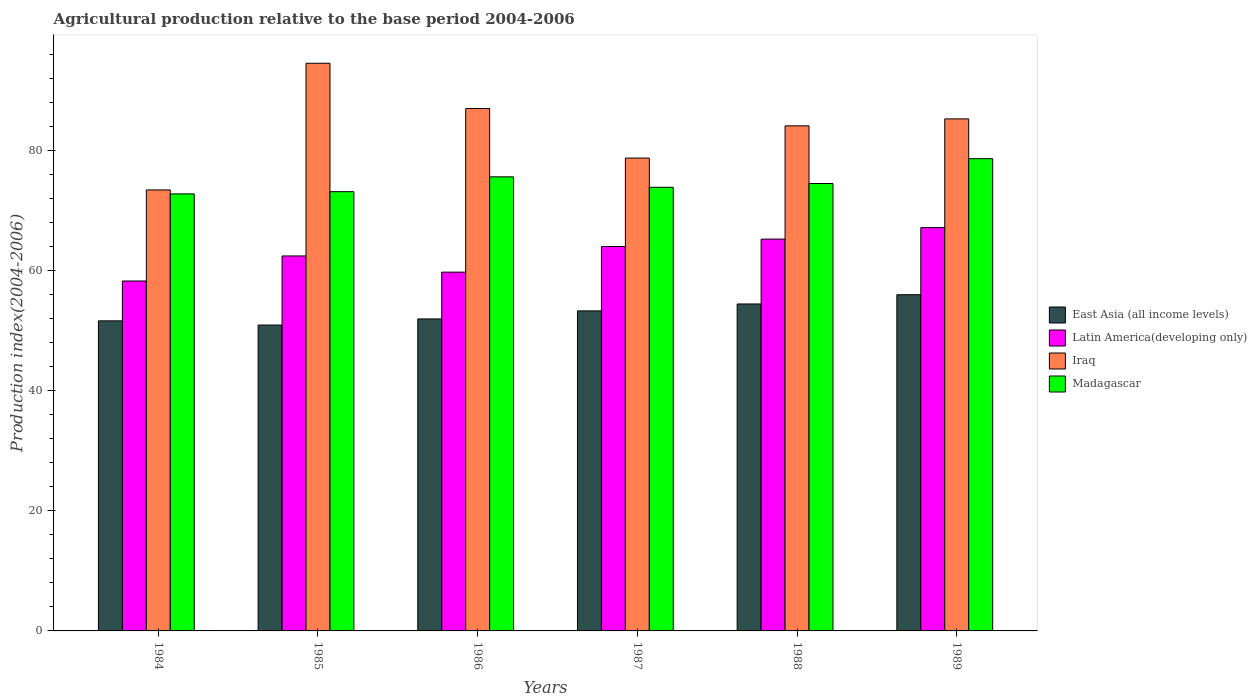How many groups of bars are there?
Keep it short and to the point. 6. How many bars are there on the 6th tick from the left?
Your response must be concise. 4. How many bars are there on the 3rd tick from the right?
Keep it short and to the point. 4. What is the label of the 6th group of bars from the left?
Provide a succinct answer. 1989. What is the agricultural production index in Latin America(developing only) in 1984?
Give a very brief answer. 58.31. Across all years, what is the maximum agricultural production index in Latin America(developing only)?
Your answer should be compact. 67.21. Across all years, what is the minimum agricultural production index in Latin America(developing only)?
Your answer should be very brief. 58.31. In which year was the agricultural production index in Iraq maximum?
Provide a succinct answer. 1985. What is the total agricultural production index in Latin America(developing only) in the graph?
Your answer should be very brief. 377.16. What is the difference between the agricultural production index in Madagascar in 1986 and that in 1988?
Keep it short and to the point. 1.11. What is the difference between the agricultural production index in East Asia (all income levels) in 1986 and the agricultural production index in Madagascar in 1984?
Offer a terse response. -20.84. What is the average agricultural production index in Madagascar per year?
Your response must be concise. 74.81. In the year 1988, what is the difference between the agricultural production index in Iraq and agricultural production index in Latin America(developing only)?
Your answer should be very brief. 18.87. In how many years, is the agricultural production index in East Asia (all income levels) greater than 28?
Keep it short and to the point. 6. What is the ratio of the agricultural production index in Iraq in 1986 to that in 1989?
Keep it short and to the point. 1.02. Is the difference between the agricultural production index in Iraq in 1988 and 1989 greater than the difference between the agricultural production index in Latin America(developing only) in 1988 and 1989?
Your answer should be very brief. Yes. What is the difference between the highest and the second highest agricultural production index in East Asia (all income levels)?
Ensure brevity in your answer.  1.54. What is the difference between the highest and the lowest agricultural production index in East Asia (all income levels)?
Your answer should be compact. 5.06. Is the sum of the agricultural production index in Latin America(developing only) in 1985 and 1987 greater than the maximum agricultural production index in Madagascar across all years?
Provide a short and direct response. Yes. What does the 1st bar from the left in 1988 represents?
Your response must be concise. East Asia (all income levels). What does the 4th bar from the right in 1989 represents?
Your response must be concise. East Asia (all income levels). How many bars are there?
Ensure brevity in your answer.  24. Are all the bars in the graph horizontal?
Offer a very short reply. No. How many years are there in the graph?
Offer a terse response. 6. Does the graph contain any zero values?
Provide a succinct answer. No. Does the graph contain grids?
Make the answer very short. No. What is the title of the graph?
Your response must be concise. Agricultural production relative to the base period 2004-2006. Does "Papua New Guinea" appear as one of the legend labels in the graph?
Your response must be concise. No. What is the label or title of the Y-axis?
Offer a terse response. Production index(2004-2006). What is the Production index(2004-2006) of East Asia (all income levels) in 1984?
Your response must be concise. 51.67. What is the Production index(2004-2006) of Latin America(developing only) in 1984?
Make the answer very short. 58.31. What is the Production index(2004-2006) of Iraq in 1984?
Make the answer very short. 73.49. What is the Production index(2004-2006) of Madagascar in 1984?
Keep it short and to the point. 72.83. What is the Production index(2004-2006) in East Asia (all income levels) in 1985?
Make the answer very short. 50.97. What is the Production index(2004-2006) of Latin America(developing only) in 1985?
Offer a terse response. 62.49. What is the Production index(2004-2006) of Iraq in 1985?
Your answer should be compact. 94.6. What is the Production index(2004-2006) of Madagascar in 1985?
Your answer should be very brief. 73.2. What is the Production index(2004-2006) of East Asia (all income levels) in 1986?
Keep it short and to the point. 51.99. What is the Production index(2004-2006) of Latin America(developing only) in 1986?
Ensure brevity in your answer.  59.79. What is the Production index(2004-2006) in Iraq in 1986?
Offer a very short reply. 87.06. What is the Production index(2004-2006) of Madagascar in 1986?
Provide a short and direct response. 75.67. What is the Production index(2004-2006) in East Asia (all income levels) in 1987?
Offer a terse response. 53.33. What is the Production index(2004-2006) in Latin America(developing only) in 1987?
Give a very brief answer. 64.06. What is the Production index(2004-2006) in Iraq in 1987?
Offer a very short reply. 78.8. What is the Production index(2004-2006) in Madagascar in 1987?
Provide a succinct answer. 73.93. What is the Production index(2004-2006) of East Asia (all income levels) in 1988?
Provide a short and direct response. 54.48. What is the Production index(2004-2006) in Latin America(developing only) in 1988?
Your answer should be very brief. 65.3. What is the Production index(2004-2006) in Iraq in 1988?
Offer a very short reply. 84.17. What is the Production index(2004-2006) of Madagascar in 1988?
Keep it short and to the point. 74.56. What is the Production index(2004-2006) in East Asia (all income levels) in 1989?
Provide a succinct answer. 56.03. What is the Production index(2004-2006) of Latin America(developing only) in 1989?
Give a very brief answer. 67.21. What is the Production index(2004-2006) in Iraq in 1989?
Provide a short and direct response. 85.33. What is the Production index(2004-2006) of Madagascar in 1989?
Offer a terse response. 78.7. Across all years, what is the maximum Production index(2004-2006) in East Asia (all income levels)?
Provide a succinct answer. 56.03. Across all years, what is the maximum Production index(2004-2006) of Latin America(developing only)?
Keep it short and to the point. 67.21. Across all years, what is the maximum Production index(2004-2006) of Iraq?
Provide a short and direct response. 94.6. Across all years, what is the maximum Production index(2004-2006) of Madagascar?
Offer a very short reply. 78.7. Across all years, what is the minimum Production index(2004-2006) of East Asia (all income levels)?
Ensure brevity in your answer.  50.97. Across all years, what is the minimum Production index(2004-2006) of Latin America(developing only)?
Your answer should be very brief. 58.31. Across all years, what is the minimum Production index(2004-2006) in Iraq?
Give a very brief answer. 73.49. Across all years, what is the minimum Production index(2004-2006) in Madagascar?
Provide a succinct answer. 72.83. What is the total Production index(2004-2006) in East Asia (all income levels) in the graph?
Give a very brief answer. 318.48. What is the total Production index(2004-2006) in Latin America(developing only) in the graph?
Provide a succinct answer. 377.16. What is the total Production index(2004-2006) in Iraq in the graph?
Offer a terse response. 503.45. What is the total Production index(2004-2006) in Madagascar in the graph?
Offer a very short reply. 448.89. What is the difference between the Production index(2004-2006) in East Asia (all income levels) in 1984 and that in 1985?
Offer a terse response. 0.7. What is the difference between the Production index(2004-2006) in Latin America(developing only) in 1984 and that in 1985?
Make the answer very short. -4.17. What is the difference between the Production index(2004-2006) of Iraq in 1984 and that in 1985?
Provide a short and direct response. -21.11. What is the difference between the Production index(2004-2006) in Madagascar in 1984 and that in 1985?
Offer a terse response. -0.37. What is the difference between the Production index(2004-2006) in East Asia (all income levels) in 1984 and that in 1986?
Make the answer very short. -0.32. What is the difference between the Production index(2004-2006) in Latin America(developing only) in 1984 and that in 1986?
Offer a terse response. -1.48. What is the difference between the Production index(2004-2006) in Iraq in 1984 and that in 1986?
Give a very brief answer. -13.57. What is the difference between the Production index(2004-2006) of Madagascar in 1984 and that in 1986?
Your response must be concise. -2.84. What is the difference between the Production index(2004-2006) in East Asia (all income levels) in 1984 and that in 1987?
Keep it short and to the point. -1.66. What is the difference between the Production index(2004-2006) in Latin America(developing only) in 1984 and that in 1987?
Your answer should be very brief. -5.75. What is the difference between the Production index(2004-2006) in Iraq in 1984 and that in 1987?
Ensure brevity in your answer.  -5.31. What is the difference between the Production index(2004-2006) in East Asia (all income levels) in 1984 and that in 1988?
Make the answer very short. -2.81. What is the difference between the Production index(2004-2006) in Latin America(developing only) in 1984 and that in 1988?
Keep it short and to the point. -6.98. What is the difference between the Production index(2004-2006) in Iraq in 1984 and that in 1988?
Your response must be concise. -10.68. What is the difference between the Production index(2004-2006) in Madagascar in 1984 and that in 1988?
Provide a short and direct response. -1.73. What is the difference between the Production index(2004-2006) in East Asia (all income levels) in 1984 and that in 1989?
Give a very brief answer. -4.36. What is the difference between the Production index(2004-2006) in Latin America(developing only) in 1984 and that in 1989?
Offer a terse response. -8.9. What is the difference between the Production index(2004-2006) of Iraq in 1984 and that in 1989?
Offer a very short reply. -11.84. What is the difference between the Production index(2004-2006) of Madagascar in 1984 and that in 1989?
Offer a very short reply. -5.87. What is the difference between the Production index(2004-2006) of East Asia (all income levels) in 1985 and that in 1986?
Your answer should be compact. -1.02. What is the difference between the Production index(2004-2006) of Latin America(developing only) in 1985 and that in 1986?
Your response must be concise. 2.7. What is the difference between the Production index(2004-2006) in Iraq in 1985 and that in 1986?
Offer a very short reply. 7.54. What is the difference between the Production index(2004-2006) of Madagascar in 1985 and that in 1986?
Your answer should be compact. -2.47. What is the difference between the Production index(2004-2006) of East Asia (all income levels) in 1985 and that in 1987?
Give a very brief answer. -2.36. What is the difference between the Production index(2004-2006) in Latin America(developing only) in 1985 and that in 1987?
Make the answer very short. -1.57. What is the difference between the Production index(2004-2006) of Iraq in 1985 and that in 1987?
Your answer should be very brief. 15.8. What is the difference between the Production index(2004-2006) of Madagascar in 1985 and that in 1987?
Provide a short and direct response. -0.73. What is the difference between the Production index(2004-2006) in East Asia (all income levels) in 1985 and that in 1988?
Offer a very short reply. -3.51. What is the difference between the Production index(2004-2006) of Latin America(developing only) in 1985 and that in 1988?
Your answer should be very brief. -2.81. What is the difference between the Production index(2004-2006) of Iraq in 1985 and that in 1988?
Provide a short and direct response. 10.43. What is the difference between the Production index(2004-2006) of Madagascar in 1985 and that in 1988?
Ensure brevity in your answer.  -1.36. What is the difference between the Production index(2004-2006) in East Asia (all income levels) in 1985 and that in 1989?
Provide a succinct answer. -5.06. What is the difference between the Production index(2004-2006) of Latin America(developing only) in 1985 and that in 1989?
Ensure brevity in your answer.  -4.72. What is the difference between the Production index(2004-2006) in Iraq in 1985 and that in 1989?
Your answer should be compact. 9.27. What is the difference between the Production index(2004-2006) in East Asia (all income levels) in 1986 and that in 1987?
Your answer should be compact. -1.34. What is the difference between the Production index(2004-2006) of Latin America(developing only) in 1986 and that in 1987?
Your answer should be compact. -4.27. What is the difference between the Production index(2004-2006) in Iraq in 1986 and that in 1987?
Offer a very short reply. 8.26. What is the difference between the Production index(2004-2006) in Madagascar in 1986 and that in 1987?
Give a very brief answer. 1.74. What is the difference between the Production index(2004-2006) in East Asia (all income levels) in 1986 and that in 1988?
Provide a short and direct response. -2.49. What is the difference between the Production index(2004-2006) of Latin America(developing only) in 1986 and that in 1988?
Your answer should be compact. -5.5. What is the difference between the Production index(2004-2006) in Iraq in 1986 and that in 1988?
Your answer should be very brief. 2.89. What is the difference between the Production index(2004-2006) in Madagascar in 1986 and that in 1988?
Keep it short and to the point. 1.11. What is the difference between the Production index(2004-2006) in East Asia (all income levels) in 1986 and that in 1989?
Your answer should be very brief. -4.04. What is the difference between the Production index(2004-2006) of Latin America(developing only) in 1986 and that in 1989?
Your response must be concise. -7.42. What is the difference between the Production index(2004-2006) in Iraq in 1986 and that in 1989?
Offer a terse response. 1.73. What is the difference between the Production index(2004-2006) of Madagascar in 1986 and that in 1989?
Your answer should be very brief. -3.03. What is the difference between the Production index(2004-2006) of East Asia (all income levels) in 1987 and that in 1988?
Make the answer very short. -1.15. What is the difference between the Production index(2004-2006) in Latin America(developing only) in 1987 and that in 1988?
Keep it short and to the point. -1.24. What is the difference between the Production index(2004-2006) of Iraq in 1987 and that in 1988?
Offer a terse response. -5.37. What is the difference between the Production index(2004-2006) in Madagascar in 1987 and that in 1988?
Provide a short and direct response. -0.63. What is the difference between the Production index(2004-2006) of East Asia (all income levels) in 1987 and that in 1989?
Make the answer very short. -2.7. What is the difference between the Production index(2004-2006) of Latin America(developing only) in 1987 and that in 1989?
Give a very brief answer. -3.15. What is the difference between the Production index(2004-2006) in Iraq in 1987 and that in 1989?
Keep it short and to the point. -6.53. What is the difference between the Production index(2004-2006) in Madagascar in 1987 and that in 1989?
Keep it short and to the point. -4.77. What is the difference between the Production index(2004-2006) of East Asia (all income levels) in 1988 and that in 1989?
Your response must be concise. -1.54. What is the difference between the Production index(2004-2006) in Latin America(developing only) in 1988 and that in 1989?
Your answer should be very brief. -1.91. What is the difference between the Production index(2004-2006) in Iraq in 1988 and that in 1989?
Your response must be concise. -1.16. What is the difference between the Production index(2004-2006) of Madagascar in 1988 and that in 1989?
Make the answer very short. -4.14. What is the difference between the Production index(2004-2006) in East Asia (all income levels) in 1984 and the Production index(2004-2006) in Latin America(developing only) in 1985?
Your answer should be compact. -10.82. What is the difference between the Production index(2004-2006) in East Asia (all income levels) in 1984 and the Production index(2004-2006) in Iraq in 1985?
Keep it short and to the point. -42.93. What is the difference between the Production index(2004-2006) in East Asia (all income levels) in 1984 and the Production index(2004-2006) in Madagascar in 1985?
Your answer should be compact. -21.53. What is the difference between the Production index(2004-2006) in Latin America(developing only) in 1984 and the Production index(2004-2006) in Iraq in 1985?
Your answer should be very brief. -36.29. What is the difference between the Production index(2004-2006) of Latin America(developing only) in 1984 and the Production index(2004-2006) of Madagascar in 1985?
Your answer should be very brief. -14.89. What is the difference between the Production index(2004-2006) in Iraq in 1984 and the Production index(2004-2006) in Madagascar in 1985?
Keep it short and to the point. 0.29. What is the difference between the Production index(2004-2006) of East Asia (all income levels) in 1984 and the Production index(2004-2006) of Latin America(developing only) in 1986?
Your answer should be very brief. -8.12. What is the difference between the Production index(2004-2006) of East Asia (all income levels) in 1984 and the Production index(2004-2006) of Iraq in 1986?
Make the answer very short. -35.39. What is the difference between the Production index(2004-2006) of East Asia (all income levels) in 1984 and the Production index(2004-2006) of Madagascar in 1986?
Offer a terse response. -24. What is the difference between the Production index(2004-2006) of Latin America(developing only) in 1984 and the Production index(2004-2006) of Iraq in 1986?
Provide a succinct answer. -28.75. What is the difference between the Production index(2004-2006) in Latin America(developing only) in 1984 and the Production index(2004-2006) in Madagascar in 1986?
Give a very brief answer. -17.36. What is the difference between the Production index(2004-2006) of Iraq in 1984 and the Production index(2004-2006) of Madagascar in 1986?
Keep it short and to the point. -2.18. What is the difference between the Production index(2004-2006) in East Asia (all income levels) in 1984 and the Production index(2004-2006) in Latin America(developing only) in 1987?
Make the answer very short. -12.39. What is the difference between the Production index(2004-2006) of East Asia (all income levels) in 1984 and the Production index(2004-2006) of Iraq in 1987?
Offer a terse response. -27.13. What is the difference between the Production index(2004-2006) in East Asia (all income levels) in 1984 and the Production index(2004-2006) in Madagascar in 1987?
Ensure brevity in your answer.  -22.26. What is the difference between the Production index(2004-2006) in Latin America(developing only) in 1984 and the Production index(2004-2006) in Iraq in 1987?
Your answer should be very brief. -20.49. What is the difference between the Production index(2004-2006) of Latin America(developing only) in 1984 and the Production index(2004-2006) of Madagascar in 1987?
Provide a succinct answer. -15.62. What is the difference between the Production index(2004-2006) in Iraq in 1984 and the Production index(2004-2006) in Madagascar in 1987?
Offer a terse response. -0.44. What is the difference between the Production index(2004-2006) in East Asia (all income levels) in 1984 and the Production index(2004-2006) in Latin America(developing only) in 1988?
Your response must be concise. -13.62. What is the difference between the Production index(2004-2006) in East Asia (all income levels) in 1984 and the Production index(2004-2006) in Iraq in 1988?
Your answer should be compact. -32.5. What is the difference between the Production index(2004-2006) of East Asia (all income levels) in 1984 and the Production index(2004-2006) of Madagascar in 1988?
Keep it short and to the point. -22.89. What is the difference between the Production index(2004-2006) in Latin America(developing only) in 1984 and the Production index(2004-2006) in Iraq in 1988?
Make the answer very short. -25.86. What is the difference between the Production index(2004-2006) of Latin America(developing only) in 1984 and the Production index(2004-2006) of Madagascar in 1988?
Offer a terse response. -16.25. What is the difference between the Production index(2004-2006) in Iraq in 1984 and the Production index(2004-2006) in Madagascar in 1988?
Give a very brief answer. -1.07. What is the difference between the Production index(2004-2006) in East Asia (all income levels) in 1984 and the Production index(2004-2006) in Latin America(developing only) in 1989?
Offer a very short reply. -15.54. What is the difference between the Production index(2004-2006) in East Asia (all income levels) in 1984 and the Production index(2004-2006) in Iraq in 1989?
Your answer should be very brief. -33.66. What is the difference between the Production index(2004-2006) of East Asia (all income levels) in 1984 and the Production index(2004-2006) of Madagascar in 1989?
Your answer should be very brief. -27.03. What is the difference between the Production index(2004-2006) of Latin America(developing only) in 1984 and the Production index(2004-2006) of Iraq in 1989?
Keep it short and to the point. -27.02. What is the difference between the Production index(2004-2006) in Latin America(developing only) in 1984 and the Production index(2004-2006) in Madagascar in 1989?
Offer a terse response. -20.39. What is the difference between the Production index(2004-2006) of Iraq in 1984 and the Production index(2004-2006) of Madagascar in 1989?
Keep it short and to the point. -5.21. What is the difference between the Production index(2004-2006) of East Asia (all income levels) in 1985 and the Production index(2004-2006) of Latin America(developing only) in 1986?
Your response must be concise. -8.82. What is the difference between the Production index(2004-2006) in East Asia (all income levels) in 1985 and the Production index(2004-2006) in Iraq in 1986?
Keep it short and to the point. -36.09. What is the difference between the Production index(2004-2006) in East Asia (all income levels) in 1985 and the Production index(2004-2006) in Madagascar in 1986?
Ensure brevity in your answer.  -24.7. What is the difference between the Production index(2004-2006) of Latin America(developing only) in 1985 and the Production index(2004-2006) of Iraq in 1986?
Give a very brief answer. -24.57. What is the difference between the Production index(2004-2006) in Latin America(developing only) in 1985 and the Production index(2004-2006) in Madagascar in 1986?
Provide a succinct answer. -13.18. What is the difference between the Production index(2004-2006) of Iraq in 1985 and the Production index(2004-2006) of Madagascar in 1986?
Keep it short and to the point. 18.93. What is the difference between the Production index(2004-2006) in East Asia (all income levels) in 1985 and the Production index(2004-2006) in Latin America(developing only) in 1987?
Provide a succinct answer. -13.09. What is the difference between the Production index(2004-2006) of East Asia (all income levels) in 1985 and the Production index(2004-2006) of Iraq in 1987?
Provide a short and direct response. -27.83. What is the difference between the Production index(2004-2006) in East Asia (all income levels) in 1985 and the Production index(2004-2006) in Madagascar in 1987?
Keep it short and to the point. -22.96. What is the difference between the Production index(2004-2006) of Latin America(developing only) in 1985 and the Production index(2004-2006) of Iraq in 1987?
Make the answer very short. -16.31. What is the difference between the Production index(2004-2006) of Latin America(developing only) in 1985 and the Production index(2004-2006) of Madagascar in 1987?
Give a very brief answer. -11.44. What is the difference between the Production index(2004-2006) of Iraq in 1985 and the Production index(2004-2006) of Madagascar in 1987?
Give a very brief answer. 20.67. What is the difference between the Production index(2004-2006) in East Asia (all income levels) in 1985 and the Production index(2004-2006) in Latin America(developing only) in 1988?
Your answer should be very brief. -14.32. What is the difference between the Production index(2004-2006) in East Asia (all income levels) in 1985 and the Production index(2004-2006) in Iraq in 1988?
Make the answer very short. -33.2. What is the difference between the Production index(2004-2006) in East Asia (all income levels) in 1985 and the Production index(2004-2006) in Madagascar in 1988?
Give a very brief answer. -23.59. What is the difference between the Production index(2004-2006) of Latin America(developing only) in 1985 and the Production index(2004-2006) of Iraq in 1988?
Offer a very short reply. -21.68. What is the difference between the Production index(2004-2006) in Latin America(developing only) in 1985 and the Production index(2004-2006) in Madagascar in 1988?
Your answer should be compact. -12.07. What is the difference between the Production index(2004-2006) of Iraq in 1985 and the Production index(2004-2006) of Madagascar in 1988?
Your answer should be very brief. 20.04. What is the difference between the Production index(2004-2006) of East Asia (all income levels) in 1985 and the Production index(2004-2006) of Latin America(developing only) in 1989?
Offer a very short reply. -16.24. What is the difference between the Production index(2004-2006) of East Asia (all income levels) in 1985 and the Production index(2004-2006) of Iraq in 1989?
Keep it short and to the point. -34.36. What is the difference between the Production index(2004-2006) in East Asia (all income levels) in 1985 and the Production index(2004-2006) in Madagascar in 1989?
Give a very brief answer. -27.73. What is the difference between the Production index(2004-2006) in Latin America(developing only) in 1985 and the Production index(2004-2006) in Iraq in 1989?
Your answer should be very brief. -22.84. What is the difference between the Production index(2004-2006) in Latin America(developing only) in 1985 and the Production index(2004-2006) in Madagascar in 1989?
Offer a very short reply. -16.21. What is the difference between the Production index(2004-2006) in East Asia (all income levels) in 1986 and the Production index(2004-2006) in Latin America(developing only) in 1987?
Ensure brevity in your answer.  -12.07. What is the difference between the Production index(2004-2006) in East Asia (all income levels) in 1986 and the Production index(2004-2006) in Iraq in 1987?
Offer a very short reply. -26.81. What is the difference between the Production index(2004-2006) in East Asia (all income levels) in 1986 and the Production index(2004-2006) in Madagascar in 1987?
Your answer should be very brief. -21.94. What is the difference between the Production index(2004-2006) in Latin America(developing only) in 1986 and the Production index(2004-2006) in Iraq in 1987?
Offer a very short reply. -19.01. What is the difference between the Production index(2004-2006) in Latin America(developing only) in 1986 and the Production index(2004-2006) in Madagascar in 1987?
Ensure brevity in your answer.  -14.14. What is the difference between the Production index(2004-2006) of Iraq in 1986 and the Production index(2004-2006) of Madagascar in 1987?
Offer a very short reply. 13.13. What is the difference between the Production index(2004-2006) in East Asia (all income levels) in 1986 and the Production index(2004-2006) in Latin America(developing only) in 1988?
Keep it short and to the point. -13.31. What is the difference between the Production index(2004-2006) of East Asia (all income levels) in 1986 and the Production index(2004-2006) of Iraq in 1988?
Provide a succinct answer. -32.18. What is the difference between the Production index(2004-2006) of East Asia (all income levels) in 1986 and the Production index(2004-2006) of Madagascar in 1988?
Your answer should be compact. -22.57. What is the difference between the Production index(2004-2006) in Latin America(developing only) in 1986 and the Production index(2004-2006) in Iraq in 1988?
Make the answer very short. -24.38. What is the difference between the Production index(2004-2006) in Latin America(developing only) in 1986 and the Production index(2004-2006) in Madagascar in 1988?
Give a very brief answer. -14.77. What is the difference between the Production index(2004-2006) in East Asia (all income levels) in 1986 and the Production index(2004-2006) in Latin America(developing only) in 1989?
Your answer should be compact. -15.22. What is the difference between the Production index(2004-2006) of East Asia (all income levels) in 1986 and the Production index(2004-2006) of Iraq in 1989?
Keep it short and to the point. -33.34. What is the difference between the Production index(2004-2006) in East Asia (all income levels) in 1986 and the Production index(2004-2006) in Madagascar in 1989?
Provide a short and direct response. -26.71. What is the difference between the Production index(2004-2006) of Latin America(developing only) in 1986 and the Production index(2004-2006) of Iraq in 1989?
Ensure brevity in your answer.  -25.54. What is the difference between the Production index(2004-2006) in Latin America(developing only) in 1986 and the Production index(2004-2006) in Madagascar in 1989?
Offer a terse response. -18.91. What is the difference between the Production index(2004-2006) in Iraq in 1986 and the Production index(2004-2006) in Madagascar in 1989?
Give a very brief answer. 8.36. What is the difference between the Production index(2004-2006) of East Asia (all income levels) in 1987 and the Production index(2004-2006) of Latin America(developing only) in 1988?
Give a very brief answer. -11.96. What is the difference between the Production index(2004-2006) of East Asia (all income levels) in 1987 and the Production index(2004-2006) of Iraq in 1988?
Your response must be concise. -30.84. What is the difference between the Production index(2004-2006) in East Asia (all income levels) in 1987 and the Production index(2004-2006) in Madagascar in 1988?
Your response must be concise. -21.23. What is the difference between the Production index(2004-2006) of Latin America(developing only) in 1987 and the Production index(2004-2006) of Iraq in 1988?
Provide a short and direct response. -20.11. What is the difference between the Production index(2004-2006) of Latin America(developing only) in 1987 and the Production index(2004-2006) of Madagascar in 1988?
Make the answer very short. -10.5. What is the difference between the Production index(2004-2006) in Iraq in 1987 and the Production index(2004-2006) in Madagascar in 1988?
Your answer should be very brief. 4.24. What is the difference between the Production index(2004-2006) of East Asia (all income levels) in 1987 and the Production index(2004-2006) of Latin America(developing only) in 1989?
Your answer should be compact. -13.88. What is the difference between the Production index(2004-2006) in East Asia (all income levels) in 1987 and the Production index(2004-2006) in Iraq in 1989?
Your answer should be very brief. -32. What is the difference between the Production index(2004-2006) of East Asia (all income levels) in 1987 and the Production index(2004-2006) of Madagascar in 1989?
Your answer should be very brief. -25.37. What is the difference between the Production index(2004-2006) of Latin America(developing only) in 1987 and the Production index(2004-2006) of Iraq in 1989?
Offer a very short reply. -21.27. What is the difference between the Production index(2004-2006) of Latin America(developing only) in 1987 and the Production index(2004-2006) of Madagascar in 1989?
Ensure brevity in your answer.  -14.64. What is the difference between the Production index(2004-2006) in East Asia (all income levels) in 1988 and the Production index(2004-2006) in Latin America(developing only) in 1989?
Your answer should be compact. -12.72. What is the difference between the Production index(2004-2006) of East Asia (all income levels) in 1988 and the Production index(2004-2006) of Iraq in 1989?
Keep it short and to the point. -30.85. What is the difference between the Production index(2004-2006) in East Asia (all income levels) in 1988 and the Production index(2004-2006) in Madagascar in 1989?
Provide a succinct answer. -24.22. What is the difference between the Production index(2004-2006) of Latin America(developing only) in 1988 and the Production index(2004-2006) of Iraq in 1989?
Give a very brief answer. -20.03. What is the difference between the Production index(2004-2006) in Latin America(developing only) in 1988 and the Production index(2004-2006) in Madagascar in 1989?
Ensure brevity in your answer.  -13.4. What is the difference between the Production index(2004-2006) of Iraq in 1988 and the Production index(2004-2006) of Madagascar in 1989?
Your answer should be compact. 5.47. What is the average Production index(2004-2006) in East Asia (all income levels) per year?
Provide a short and direct response. 53.08. What is the average Production index(2004-2006) of Latin America(developing only) per year?
Your answer should be very brief. 62.86. What is the average Production index(2004-2006) of Iraq per year?
Provide a short and direct response. 83.91. What is the average Production index(2004-2006) of Madagascar per year?
Offer a terse response. 74.81. In the year 1984, what is the difference between the Production index(2004-2006) in East Asia (all income levels) and Production index(2004-2006) in Latin America(developing only)?
Give a very brief answer. -6.64. In the year 1984, what is the difference between the Production index(2004-2006) of East Asia (all income levels) and Production index(2004-2006) of Iraq?
Make the answer very short. -21.82. In the year 1984, what is the difference between the Production index(2004-2006) in East Asia (all income levels) and Production index(2004-2006) in Madagascar?
Keep it short and to the point. -21.16. In the year 1984, what is the difference between the Production index(2004-2006) in Latin America(developing only) and Production index(2004-2006) in Iraq?
Offer a terse response. -15.18. In the year 1984, what is the difference between the Production index(2004-2006) in Latin America(developing only) and Production index(2004-2006) in Madagascar?
Make the answer very short. -14.52. In the year 1984, what is the difference between the Production index(2004-2006) of Iraq and Production index(2004-2006) of Madagascar?
Your answer should be very brief. 0.66. In the year 1985, what is the difference between the Production index(2004-2006) of East Asia (all income levels) and Production index(2004-2006) of Latin America(developing only)?
Offer a very short reply. -11.52. In the year 1985, what is the difference between the Production index(2004-2006) of East Asia (all income levels) and Production index(2004-2006) of Iraq?
Make the answer very short. -43.63. In the year 1985, what is the difference between the Production index(2004-2006) of East Asia (all income levels) and Production index(2004-2006) of Madagascar?
Ensure brevity in your answer.  -22.23. In the year 1985, what is the difference between the Production index(2004-2006) in Latin America(developing only) and Production index(2004-2006) in Iraq?
Provide a succinct answer. -32.11. In the year 1985, what is the difference between the Production index(2004-2006) in Latin America(developing only) and Production index(2004-2006) in Madagascar?
Offer a very short reply. -10.71. In the year 1985, what is the difference between the Production index(2004-2006) in Iraq and Production index(2004-2006) in Madagascar?
Ensure brevity in your answer.  21.4. In the year 1986, what is the difference between the Production index(2004-2006) in East Asia (all income levels) and Production index(2004-2006) in Latin America(developing only)?
Your answer should be compact. -7.8. In the year 1986, what is the difference between the Production index(2004-2006) in East Asia (all income levels) and Production index(2004-2006) in Iraq?
Offer a very short reply. -35.07. In the year 1986, what is the difference between the Production index(2004-2006) in East Asia (all income levels) and Production index(2004-2006) in Madagascar?
Your answer should be very brief. -23.68. In the year 1986, what is the difference between the Production index(2004-2006) in Latin America(developing only) and Production index(2004-2006) in Iraq?
Offer a very short reply. -27.27. In the year 1986, what is the difference between the Production index(2004-2006) of Latin America(developing only) and Production index(2004-2006) of Madagascar?
Make the answer very short. -15.88. In the year 1986, what is the difference between the Production index(2004-2006) in Iraq and Production index(2004-2006) in Madagascar?
Ensure brevity in your answer.  11.39. In the year 1987, what is the difference between the Production index(2004-2006) of East Asia (all income levels) and Production index(2004-2006) of Latin America(developing only)?
Your response must be concise. -10.73. In the year 1987, what is the difference between the Production index(2004-2006) in East Asia (all income levels) and Production index(2004-2006) in Iraq?
Keep it short and to the point. -25.47. In the year 1987, what is the difference between the Production index(2004-2006) in East Asia (all income levels) and Production index(2004-2006) in Madagascar?
Give a very brief answer. -20.6. In the year 1987, what is the difference between the Production index(2004-2006) of Latin America(developing only) and Production index(2004-2006) of Iraq?
Provide a succinct answer. -14.74. In the year 1987, what is the difference between the Production index(2004-2006) in Latin America(developing only) and Production index(2004-2006) in Madagascar?
Give a very brief answer. -9.87. In the year 1987, what is the difference between the Production index(2004-2006) in Iraq and Production index(2004-2006) in Madagascar?
Ensure brevity in your answer.  4.87. In the year 1988, what is the difference between the Production index(2004-2006) of East Asia (all income levels) and Production index(2004-2006) of Latin America(developing only)?
Ensure brevity in your answer.  -10.81. In the year 1988, what is the difference between the Production index(2004-2006) in East Asia (all income levels) and Production index(2004-2006) in Iraq?
Provide a succinct answer. -29.69. In the year 1988, what is the difference between the Production index(2004-2006) of East Asia (all income levels) and Production index(2004-2006) of Madagascar?
Provide a succinct answer. -20.08. In the year 1988, what is the difference between the Production index(2004-2006) in Latin America(developing only) and Production index(2004-2006) in Iraq?
Offer a very short reply. -18.87. In the year 1988, what is the difference between the Production index(2004-2006) in Latin America(developing only) and Production index(2004-2006) in Madagascar?
Give a very brief answer. -9.26. In the year 1988, what is the difference between the Production index(2004-2006) of Iraq and Production index(2004-2006) of Madagascar?
Provide a succinct answer. 9.61. In the year 1989, what is the difference between the Production index(2004-2006) in East Asia (all income levels) and Production index(2004-2006) in Latin America(developing only)?
Your response must be concise. -11.18. In the year 1989, what is the difference between the Production index(2004-2006) of East Asia (all income levels) and Production index(2004-2006) of Iraq?
Offer a terse response. -29.3. In the year 1989, what is the difference between the Production index(2004-2006) of East Asia (all income levels) and Production index(2004-2006) of Madagascar?
Offer a terse response. -22.67. In the year 1989, what is the difference between the Production index(2004-2006) in Latin America(developing only) and Production index(2004-2006) in Iraq?
Keep it short and to the point. -18.12. In the year 1989, what is the difference between the Production index(2004-2006) in Latin America(developing only) and Production index(2004-2006) in Madagascar?
Give a very brief answer. -11.49. In the year 1989, what is the difference between the Production index(2004-2006) in Iraq and Production index(2004-2006) in Madagascar?
Offer a terse response. 6.63. What is the ratio of the Production index(2004-2006) in East Asia (all income levels) in 1984 to that in 1985?
Keep it short and to the point. 1.01. What is the ratio of the Production index(2004-2006) of Latin America(developing only) in 1984 to that in 1985?
Keep it short and to the point. 0.93. What is the ratio of the Production index(2004-2006) of Iraq in 1984 to that in 1985?
Give a very brief answer. 0.78. What is the ratio of the Production index(2004-2006) of Madagascar in 1984 to that in 1985?
Provide a short and direct response. 0.99. What is the ratio of the Production index(2004-2006) of East Asia (all income levels) in 1984 to that in 1986?
Offer a terse response. 0.99. What is the ratio of the Production index(2004-2006) in Latin America(developing only) in 1984 to that in 1986?
Offer a very short reply. 0.98. What is the ratio of the Production index(2004-2006) in Iraq in 1984 to that in 1986?
Provide a succinct answer. 0.84. What is the ratio of the Production index(2004-2006) of Madagascar in 1984 to that in 1986?
Offer a terse response. 0.96. What is the ratio of the Production index(2004-2006) of East Asia (all income levels) in 1984 to that in 1987?
Your answer should be compact. 0.97. What is the ratio of the Production index(2004-2006) in Latin America(developing only) in 1984 to that in 1987?
Offer a very short reply. 0.91. What is the ratio of the Production index(2004-2006) of Iraq in 1984 to that in 1987?
Give a very brief answer. 0.93. What is the ratio of the Production index(2004-2006) in Madagascar in 1984 to that in 1987?
Make the answer very short. 0.99. What is the ratio of the Production index(2004-2006) of East Asia (all income levels) in 1984 to that in 1988?
Offer a very short reply. 0.95. What is the ratio of the Production index(2004-2006) of Latin America(developing only) in 1984 to that in 1988?
Your response must be concise. 0.89. What is the ratio of the Production index(2004-2006) in Iraq in 1984 to that in 1988?
Your answer should be compact. 0.87. What is the ratio of the Production index(2004-2006) of Madagascar in 1984 to that in 1988?
Keep it short and to the point. 0.98. What is the ratio of the Production index(2004-2006) in East Asia (all income levels) in 1984 to that in 1989?
Your answer should be compact. 0.92. What is the ratio of the Production index(2004-2006) of Latin America(developing only) in 1984 to that in 1989?
Ensure brevity in your answer.  0.87. What is the ratio of the Production index(2004-2006) in Iraq in 1984 to that in 1989?
Ensure brevity in your answer.  0.86. What is the ratio of the Production index(2004-2006) in Madagascar in 1984 to that in 1989?
Give a very brief answer. 0.93. What is the ratio of the Production index(2004-2006) in East Asia (all income levels) in 1985 to that in 1986?
Provide a succinct answer. 0.98. What is the ratio of the Production index(2004-2006) of Latin America(developing only) in 1985 to that in 1986?
Provide a short and direct response. 1.05. What is the ratio of the Production index(2004-2006) in Iraq in 1985 to that in 1986?
Ensure brevity in your answer.  1.09. What is the ratio of the Production index(2004-2006) in Madagascar in 1985 to that in 1986?
Offer a very short reply. 0.97. What is the ratio of the Production index(2004-2006) of East Asia (all income levels) in 1985 to that in 1987?
Keep it short and to the point. 0.96. What is the ratio of the Production index(2004-2006) of Latin America(developing only) in 1985 to that in 1987?
Ensure brevity in your answer.  0.98. What is the ratio of the Production index(2004-2006) of Iraq in 1985 to that in 1987?
Your answer should be compact. 1.2. What is the ratio of the Production index(2004-2006) in Madagascar in 1985 to that in 1987?
Provide a succinct answer. 0.99. What is the ratio of the Production index(2004-2006) in East Asia (all income levels) in 1985 to that in 1988?
Offer a very short reply. 0.94. What is the ratio of the Production index(2004-2006) of Latin America(developing only) in 1985 to that in 1988?
Your answer should be compact. 0.96. What is the ratio of the Production index(2004-2006) in Iraq in 1985 to that in 1988?
Your response must be concise. 1.12. What is the ratio of the Production index(2004-2006) in Madagascar in 1985 to that in 1988?
Keep it short and to the point. 0.98. What is the ratio of the Production index(2004-2006) of East Asia (all income levels) in 1985 to that in 1989?
Your response must be concise. 0.91. What is the ratio of the Production index(2004-2006) of Latin America(developing only) in 1985 to that in 1989?
Your answer should be compact. 0.93. What is the ratio of the Production index(2004-2006) in Iraq in 1985 to that in 1989?
Offer a very short reply. 1.11. What is the ratio of the Production index(2004-2006) of Madagascar in 1985 to that in 1989?
Provide a short and direct response. 0.93. What is the ratio of the Production index(2004-2006) of East Asia (all income levels) in 1986 to that in 1987?
Ensure brevity in your answer.  0.97. What is the ratio of the Production index(2004-2006) of Latin America(developing only) in 1986 to that in 1987?
Make the answer very short. 0.93. What is the ratio of the Production index(2004-2006) of Iraq in 1986 to that in 1987?
Make the answer very short. 1.1. What is the ratio of the Production index(2004-2006) of Madagascar in 1986 to that in 1987?
Provide a succinct answer. 1.02. What is the ratio of the Production index(2004-2006) of East Asia (all income levels) in 1986 to that in 1988?
Provide a succinct answer. 0.95. What is the ratio of the Production index(2004-2006) in Latin America(developing only) in 1986 to that in 1988?
Make the answer very short. 0.92. What is the ratio of the Production index(2004-2006) of Iraq in 1986 to that in 1988?
Give a very brief answer. 1.03. What is the ratio of the Production index(2004-2006) of Madagascar in 1986 to that in 1988?
Give a very brief answer. 1.01. What is the ratio of the Production index(2004-2006) in East Asia (all income levels) in 1986 to that in 1989?
Offer a very short reply. 0.93. What is the ratio of the Production index(2004-2006) in Latin America(developing only) in 1986 to that in 1989?
Provide a succinct answer. 0.89. What is the ratio of the Production index(2004-2006) of Iraq in 1986 to that in 1989?
Offer a terse response. 1.02. What is the ratio of the Production index(2004-2006) in Madagascar in 1986 to that in 1989?
Offer a terse response. 0.96. What is the ratio of the Production index(2004-2006) in East Asia (all income levels) in 1987 to that in 1988?
Offer a very short reply. 0.98. What is the ratio of the Production index(2004-2006) of Latin America(developing only) in 1987 to that in 1988?
Provide a short and direct response. 0.98. What is the ratio of the Production index(2004-2006) of Iraq in 1987 to that in 1988?
Give a very brief answer. 0.94. What is the ratio of the Production index(2004-2006) in East Asia (all income levels) in 1987 to that in 1989?
Give a very brief answer. 0.95. What is the ratio of the Production index(2004-2006) of Latin America(developing only) in 1987 to that in 1989?
Keep it short and to the point. 0.95. What is the ratio of the Production index(2004-2006) in Iraq in 1987 to that in 1989?
Ensure brevity in your answer.  0.92. What is the ratio of the Production index(2004-2006) in Madagascar in 1987 to that in 1989?
Give a very brief answer. 0.94. What is the ratio of the Production index(2004-2006) of East Asia (all income levels) in 1988 to that in 1989?
Provide a succinct answer. 0.97. What is the ratio of the Production index(2004-2006) in Latin America(developing only) in 1988 to that in 1989?
Make the answer very short. 0.97. What is the ratio of the Production index(2004-2006) of Iraq in 1988 to that in 1989?
Give a very brief answer. 0.99. What is the ratio of the Production index(2004-2006) in Madagascar in 1988 to that in 1989?
Provide a succinct answer. 0.95. What is the difference between the highest and the second highest Production index(2004-2006) in East Asia (all income levels)?
Your answer should be compact. 1.54. What is the difference between the highest and the second highest Production index(2004-2006) of Latin America(developing only)?
Keep it short and to the point. 1.91. What is the difference between the highest and the second highest Production index(2004-2006) of Iraq?
Your answer should be compact. 7.54. What is the difference between the highest and the second highest Production index(2004-2006) in Madagascar?
Offer a very short reply. 3.03. What is the difference between the highest and the lowest Production index(2004-2006) in East Asia (all income levels)?
Provide a short and direct response. 5.06. What is the difference between the highest and the lowest Production index(2004-2006) of Latin America(developing only)?
Your answer should be very brief. 8.9. What is the difference between the highest and the lowest Production index(2004-2006) in Iraq?
Offer a very short reply. 21.11. What is the difference between the highest and the lowest Production index(2004-2006) of Madagascar?
Ensure brevity in your answer.  5.87. 